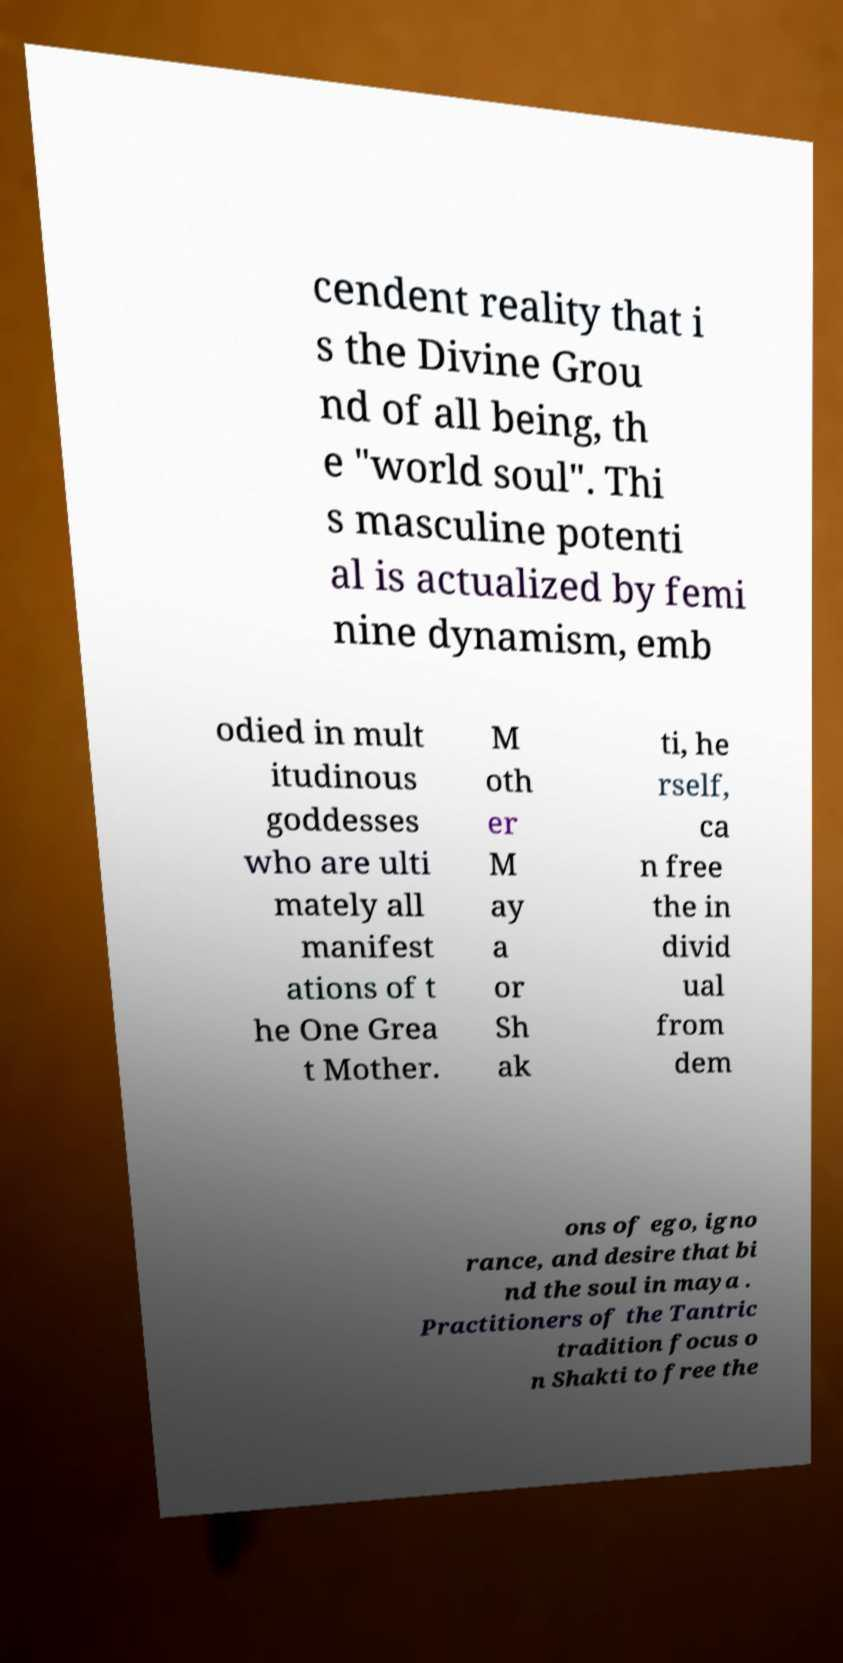I need the written content from this picture converted into text. Can you do that? cendent reality that i s the Divine Grou nd of all being, th e "world soul". Thi s masculine potenti al is actualized by femi nine dynamism, emb odied in mult itudinous goddesses who are ulti mately all manifest ations of t he One Grea t Mother. M oth er M ay a or Sh ak ti, he rself, ca n free the in divid ual from dem ons of ego, igno rance, and desire that bi nd the soul in maya . Practitioners of the Tantric tradition focus o n Shakti to free the 